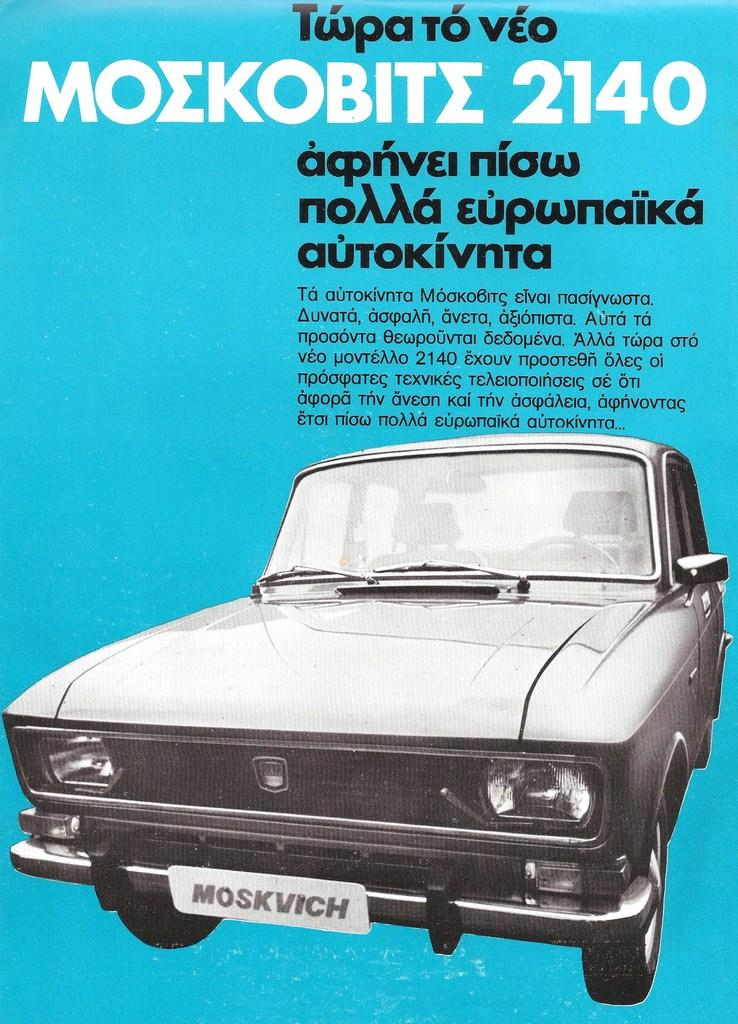What is the main image on the poster in the image? The poster contains a picture of a car. What else is featured on the poster besides the image? There are letters on the poster. What is the color of the background on the poster? The background of the poster is blue in color. What type of rhythm can be heard coming from the car in the image? There is no sound or rhythm present in the image, as it is a static poster featuring a picture of a car. Is there a twist in the car's design that can be seen in the image? The image does not provide enough detail to determine if there is a twist in the car's design. However, the focus of the image is on the overall picture of the car, not specific design elements. 